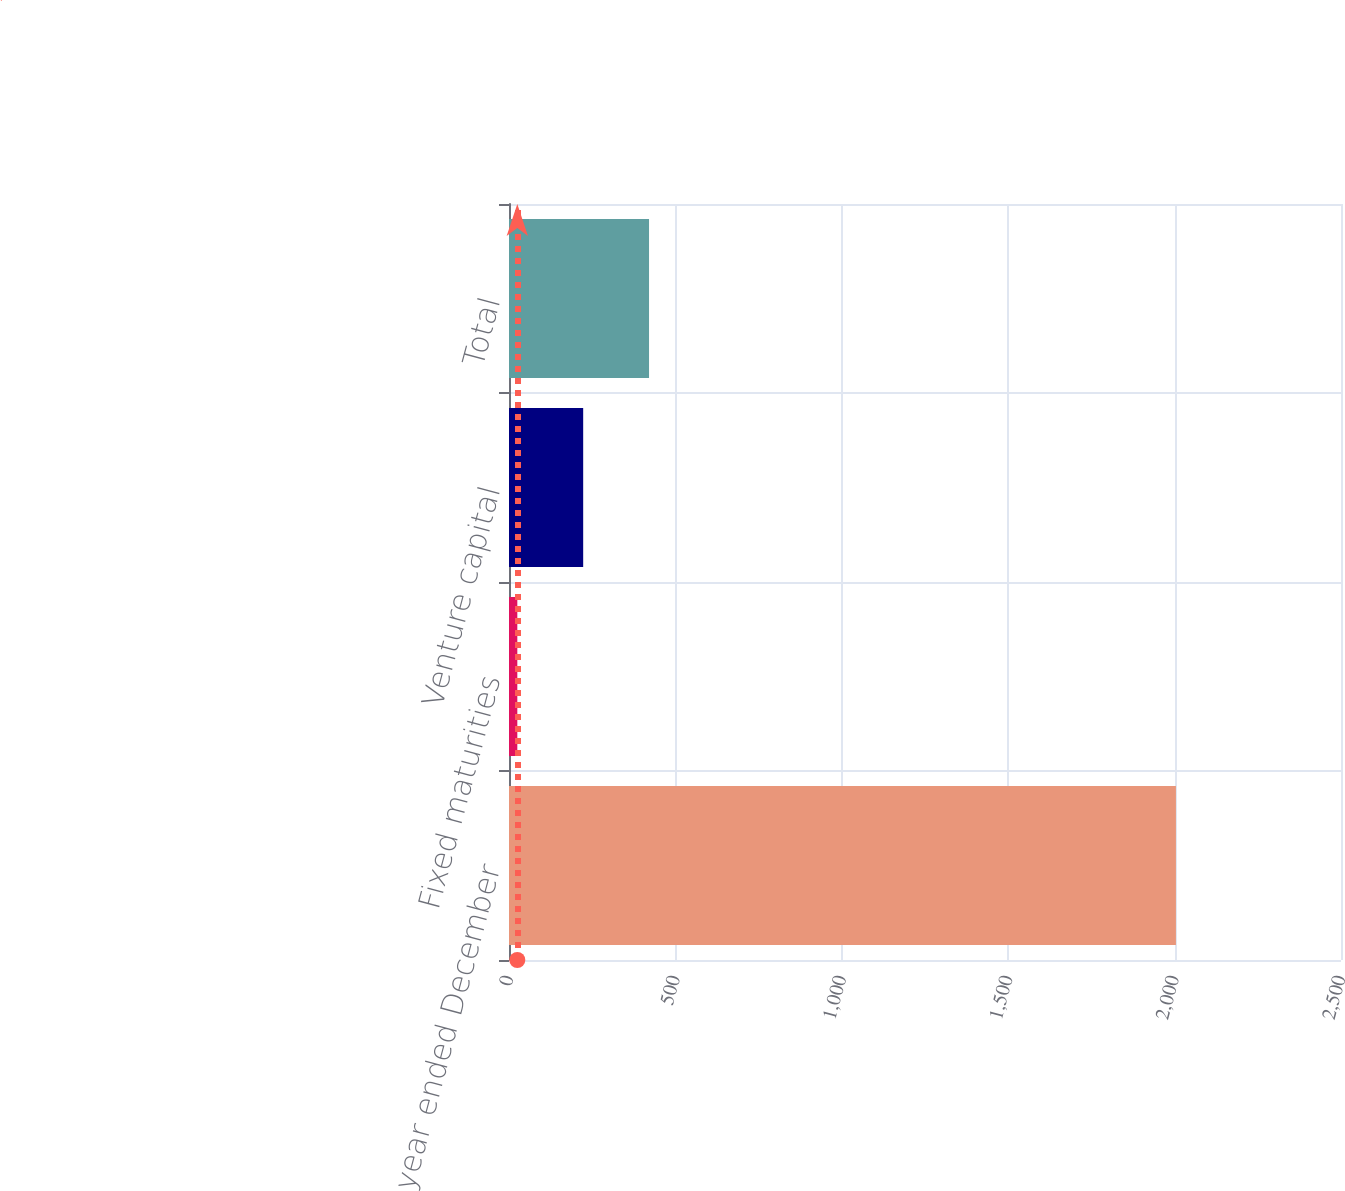Convert chart. <chart><loc_0><loc_0><loc_500><loc_500><bar_chart><fcel>(for the year ended December<fcel>Fixed maturities<fcel>Venture capital<fcel>Total<nl><fcel>2004<fcel>25<fcel>222.9<fcel>420.8<nl></chart> 